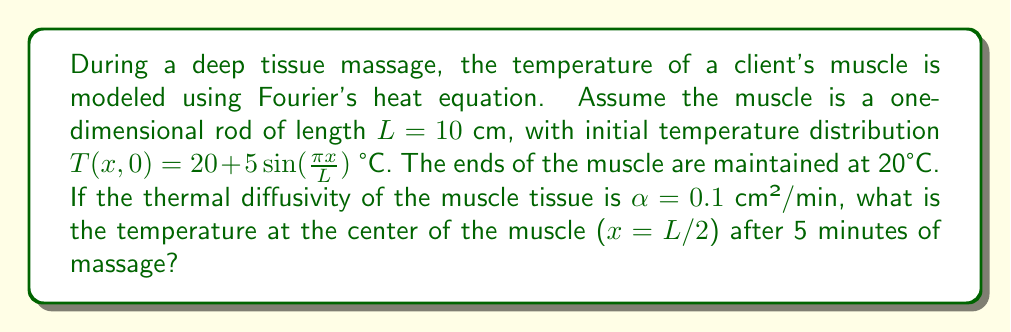Can you answer this question? To solve this problem, we'll use the solution to the one-dimensional heat equation with fixed boundary conditions:

1) The general solution to the heat equation is:

   $$T(x,t) = \sum_{n=1}^{\infty} B_n \sin(\frac{n\pi x}{L}) e^{-\alpha(\frac{n\pi}{L})^2t}$$

2) Given the initial condition $T(x,0) = 20 + 5\sin(\frac{\pi x}{L})$, we can see that only the n=1 term is present initially. Therefore:

   $$B_1 = 5, B_n = 0 \text{ for } n > 1$$

3) The solution simplifies to:

   $$T(x,t) = 20 + 5\sin(\frac{\pi x}{L}) e^{-\alpha(\frac{\pi}{L})^2t}$$

4) We need to evaluate this at x = L/2 and t = 5:

   $$T(L/2,5) = 20 + 5\sin(\frac{\pi (L/2)}{L}) e^{-\alpha(\frac{\pi}{L})^2(5)}$$

5) Simplify $\sin(\frac{\pi (L/2)}{L}) = \sin(\frac{\pi}{2}) = 1$

6) Substitute the given values: L = 10 cm, α = 0.1 cm²/min, t = 5 min

   $$T(5,5) = 20 + 5 \cdot 1 \cdot e^{-0.1(\frac{\pi}{10})^2(5)}$$

7) Calculate the exponent: $-0.1(\frac{\pi}{10})^2(5) = -0.1 \cdot \frac{\pi^2}{100} \cdot 5 \approx -0.4934$

8) Evaluate: $T(5,5) = 20 + 5e^{-0.4934} \approx 20 + 5 \cdot 0.6106 \approx 23.05$ °C
Answer: The temperature at the center of the muscle after 5 minutes of massage is approximately 23.05 °C. 